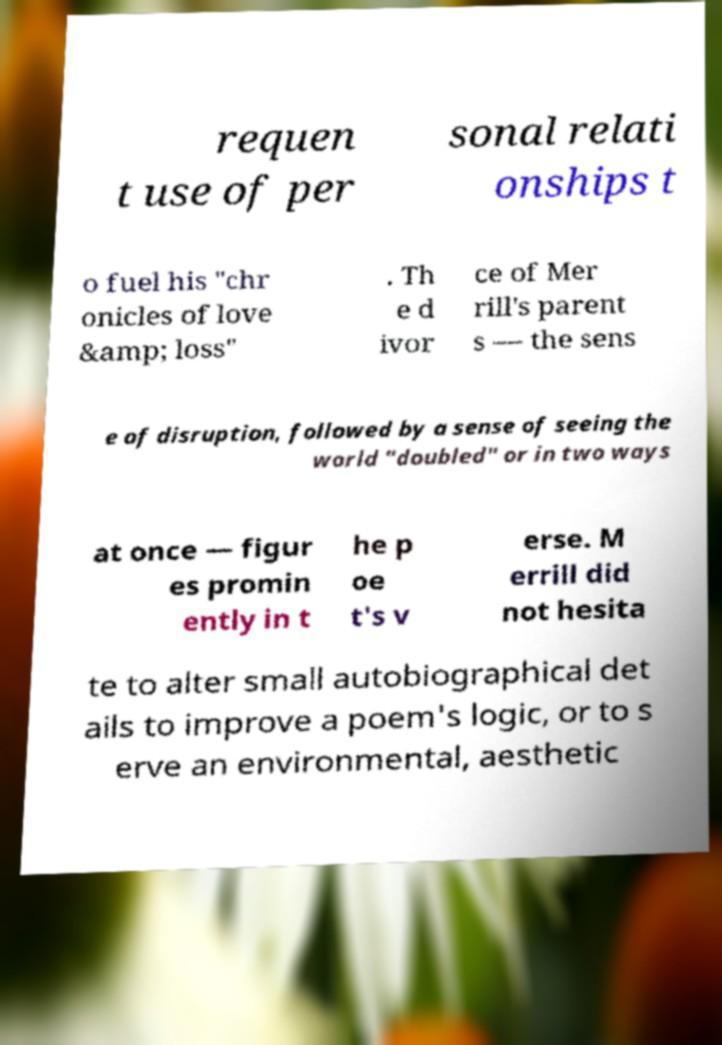Could you assist in decoding the text presented in this image and type it out clearly? requen t use of per sonal relati onships t o fuel his "chr onicles of love &amp; loss" . Th e d ivor ce of Mer rill's parent s — the sens e of disruption, followed by a sense of seeing the world "doubled" or in two ways at once — figur es promin ently in t he p oe t's v erse. M errill did not hesita te to alter small autobiographical det ails to improve a poem's logic, or to s erve an environmental, aesthetic 